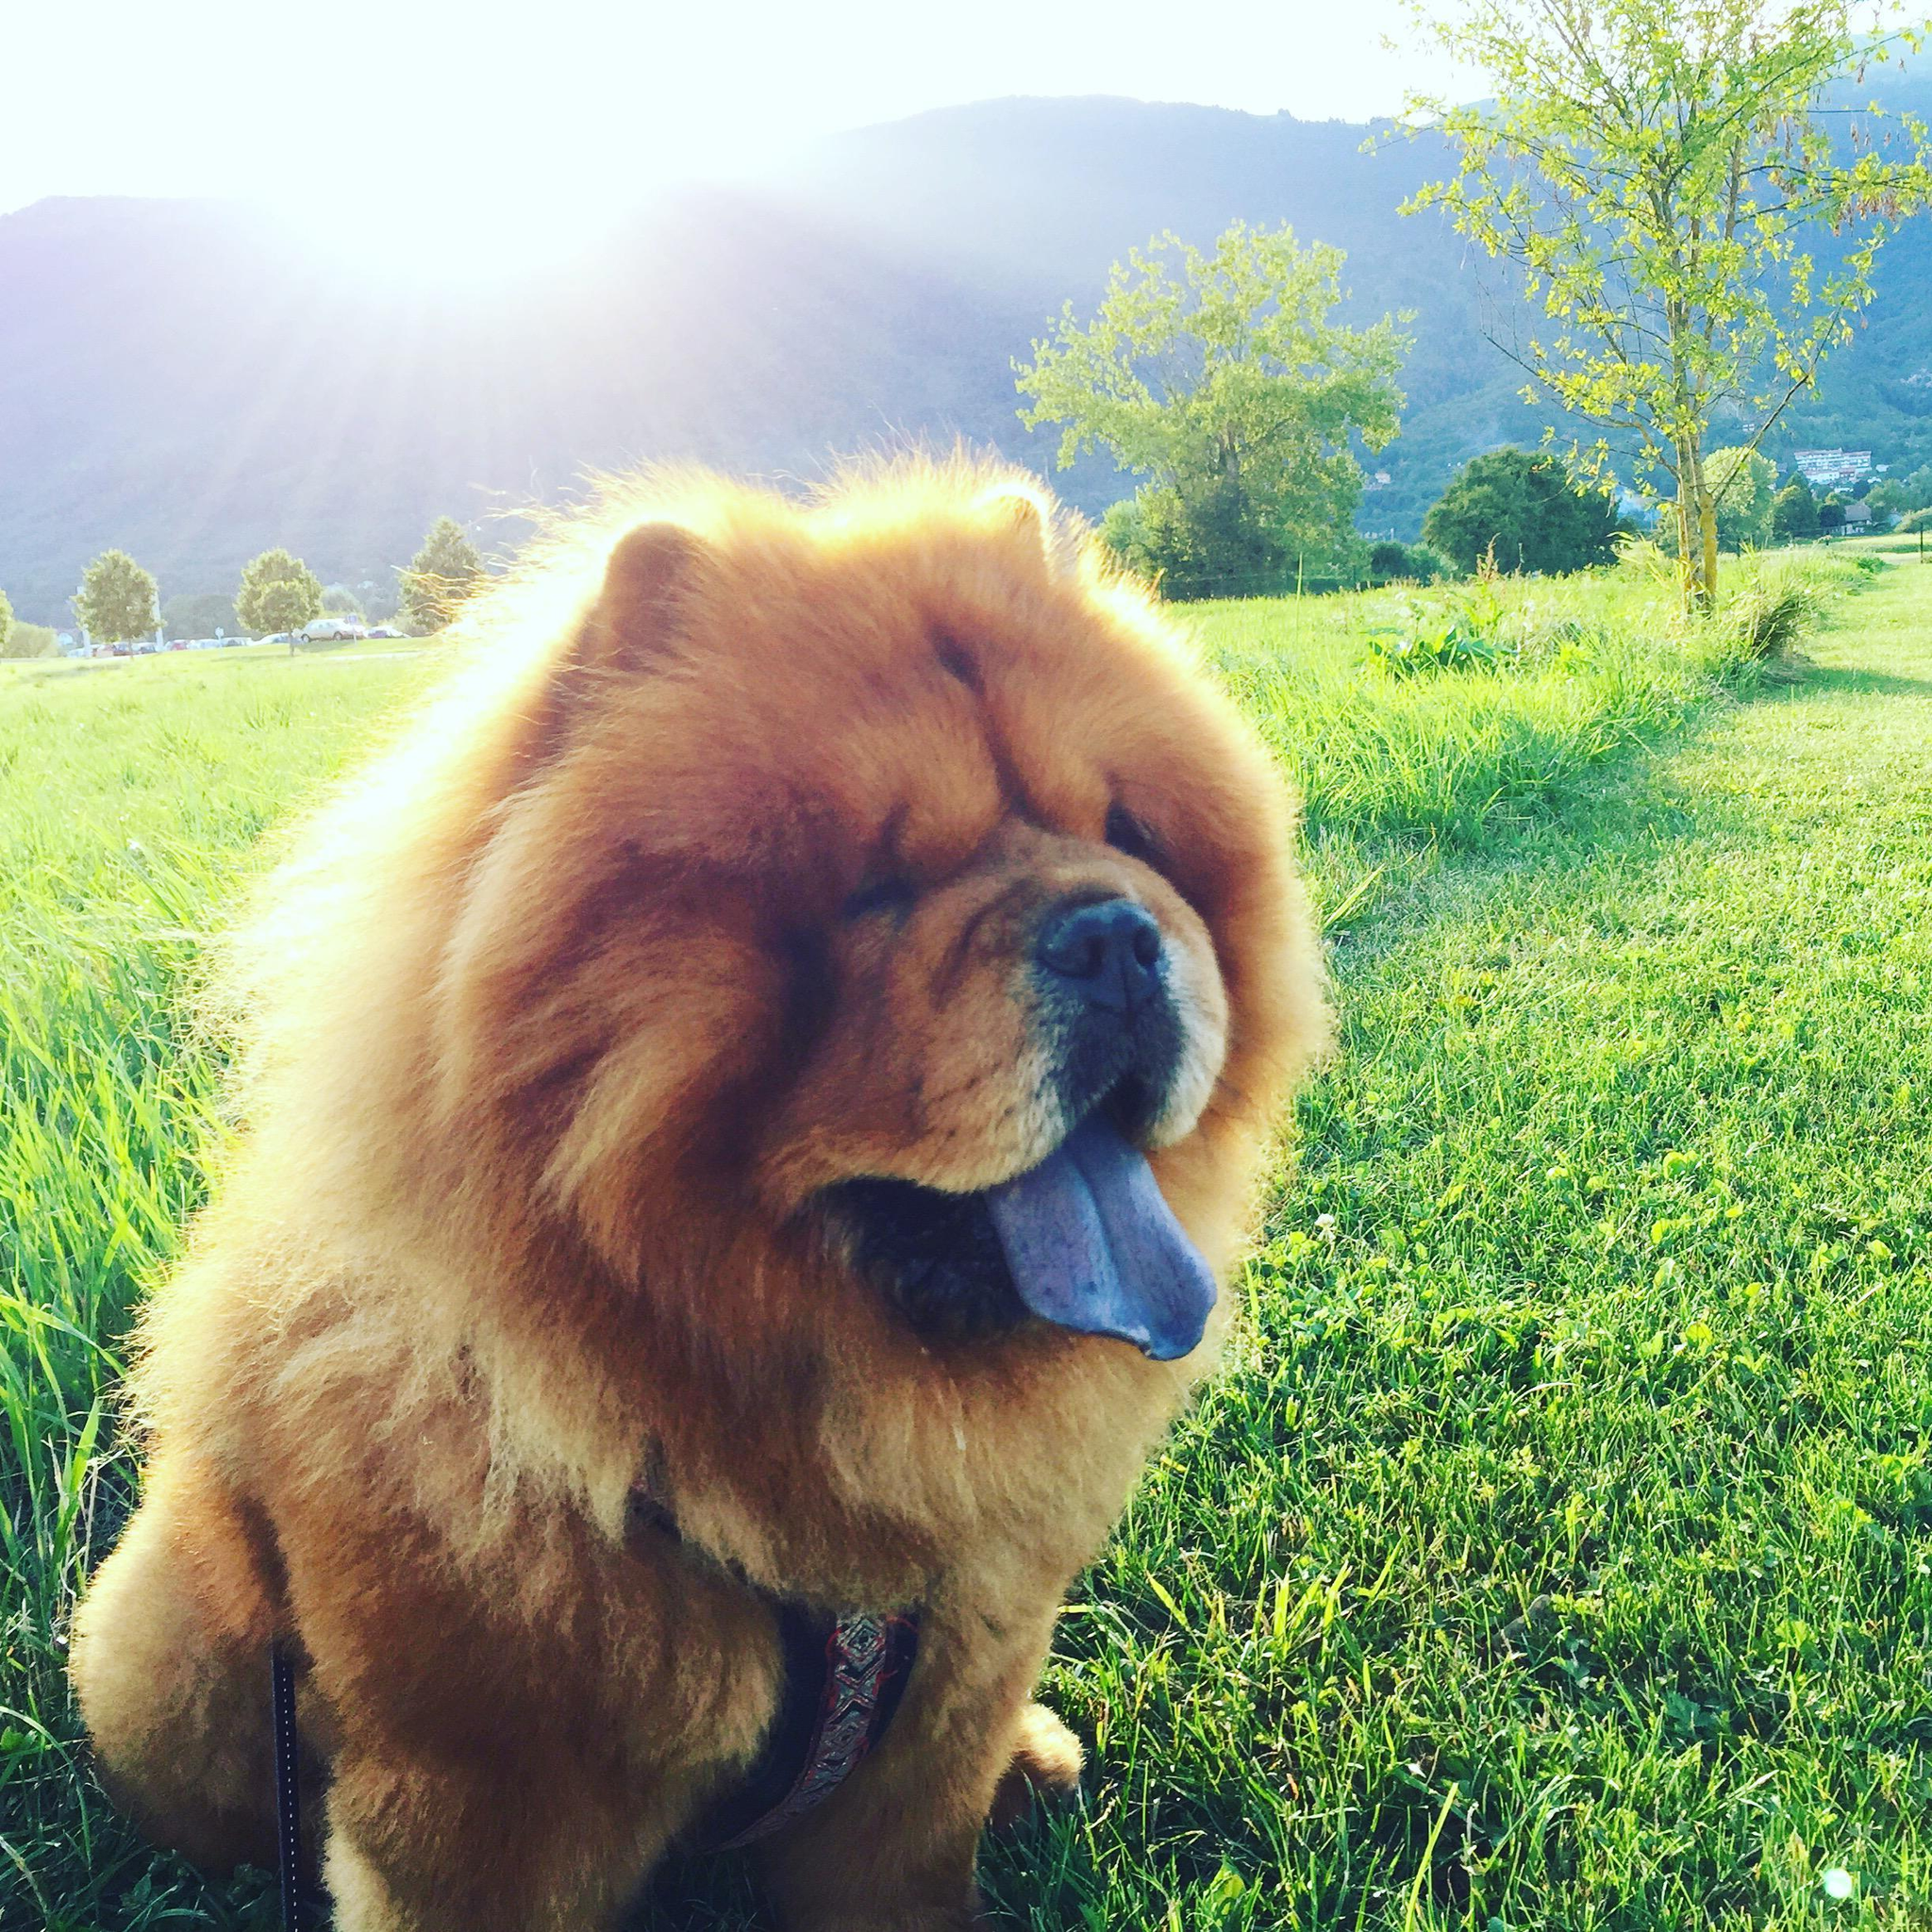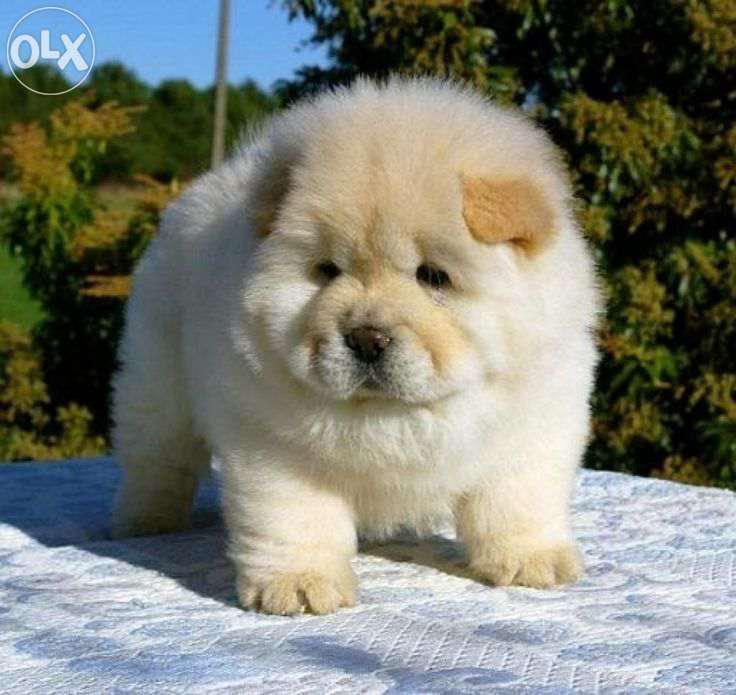The first image is the image on the left, the second image is the image on the right. Evaluate the accuracy of this statement regarding the images: "There are four dogs in total.". Is it true? Answer yes or no. No. 